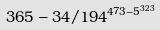<formula> <loc_0><loc_0><loc_500><loc_500>3 6 5 - 3 4 / 1 9 4 ^ { 4 7 3 - 5 ^ { 3 2 3 } }</formula> 